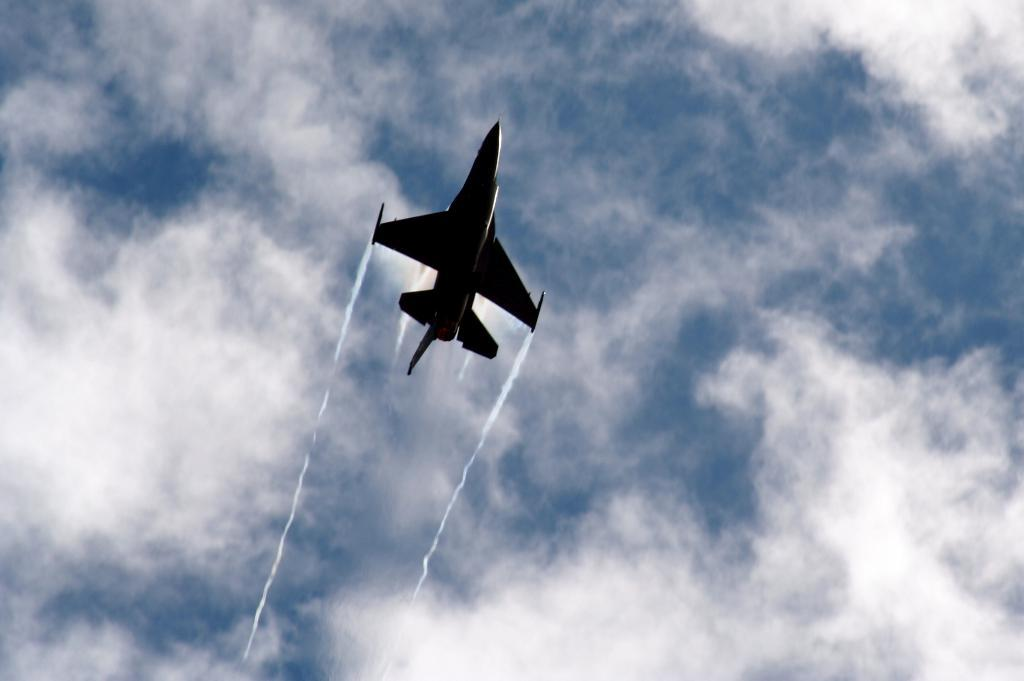What is the main subject of the image? The main subject of the image is an aeroplane. What is the aeroplane doing in the image? The aeroplane is flying in the sky. What can be seen in the background of the image? There are clouds visible in the sky in the background of the image. How many kittens are sitting on the glass in the image? There are no kittens or glass present in the image; it features an aeroplane flying in the sky with clouds in the background. 